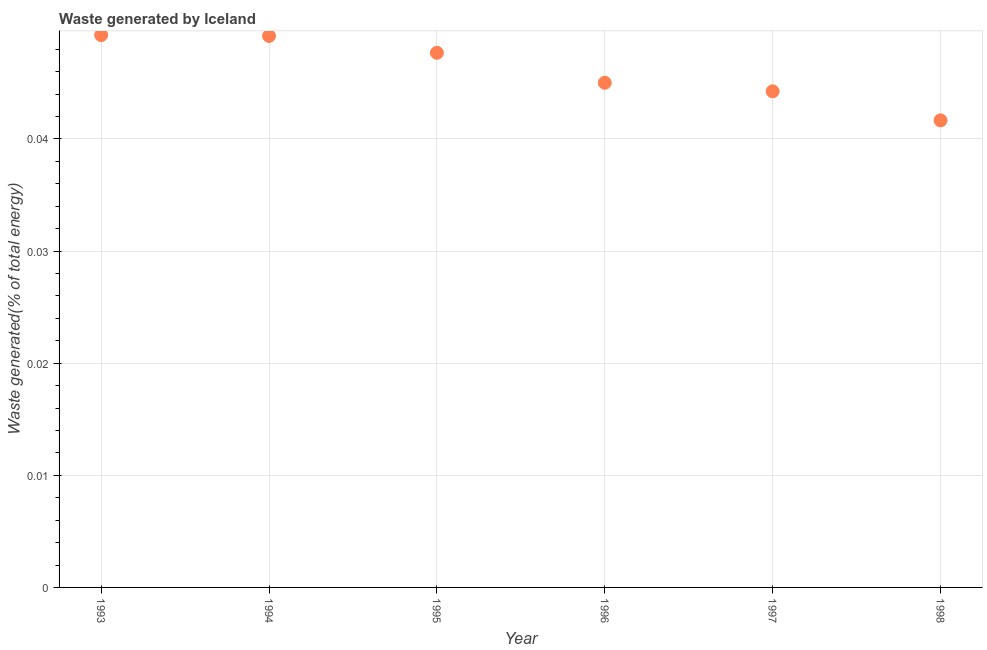What is the amount of waste generated in 1995?
Provide a succinct answer. 0.05. Across all years, what is the maximum amount of waste generated?
Give a very brief answer. 0.05. Across all years, what is the minimum amount of waste generated?
Provide a short and direct response. 0.04. In which year was the amount of waste generated maximum?
Your answer should be very brief. 1993. What is the sum of the amount of waste generated?
Your response must be concise. 0.28. What is the difference between the amount of waste generated in 1993 and 1994?
Ensure brevity in your answer.  7.597910956889248e-5. What is the average amount of waste generated per year?
Make the answer very short. 0.05. What is the median amount of waste generated?
Your answer should be very brief. 0.05. In how many years, is the amount of waste generated greater than 0.026000000000000002 %?
Provide a short and direct response. 6. What is the ratio of the amount of waste generated in 1997 to that in 1998?
Give a very brief answer. 1.06. Is the amount of waste generated in 1994 less than that in 1997?
Make the answer very short. No. Is the difference between the amount of waste generated in 1995 and 1998 greater than the difference between any two years?
Offer a terse response. No. What is the difference between the highest and the second highest amount of waste generated?
Provide a succinct answer. 7.597910956889248e-5. What is the difference between the highest and the lowest amount of waste generated?
Provide a short and direct response. 0.01. Does the graph contain any zero values?
Your response must be concise. No. Does the graph contain grids?
Offer a terse response. Yes. What is the title of the graph?
Your answer should be compact. Waste generated by Iceland. What is the label or title of the X-axis?
Offer a very short reply. Year. What is the label or title of the Y-axis?
Keep it short and to the point. Waste generated(% of total energy). What is the Waste generated(% of total energy) in 1993?
Your response must be concise. 0.05. What is the Waste generated(% of total energy) in 1994?
Keep it short and to the point. 0.05. What is the Waste generated(% of total energy) in 1995?
Give a very brief answer. 0.05. What is the Waste generated(% of total energy) in 1996?
Your answer should be very brief. 0.05. What is the Waste generated(% of total energy) in 1997?
Keep it short and to the point. 0.04. What is the Waste generated(% of total energy) in 1998?
Offer a terse response. 0.04. What is the difference between the Waste generated(% of total energy) in 1993 and 1994?
Provide a succinct answer. 8e-5. What is the difference between the Waste generated(% of total energy) in 1993 and 1995?
Keep it short and to the point. 0. What is the difference between the Waste generated(% of total energy) in 1993 and 1996?
Offer a very short reply. 0. What is the difference between the Waste generated(% of total energy) in 1993 and 1997?
Provide a short and direct response. 0.01. What is the difference between the Waste generated(% of total energy) in 1993 and 1998?
Make the answer very short. 0.01. What is the difference between the Waste generated(% of total energy) in 1994 and 1995?
Make the answer very short. 0. What is the difference between the Waste generated(% of total energy) in 1994 and 1996?
Ensure brevity in your answer.  0. What is the difference between the Waste generated(% of total energy) in 1994 and 1997?
Offer a terse response. 0. What is the difference between the Waste generated(% of total energy) in 1994 and 1998?
Give a very brief answer. 0.01. What is the difference between the Waste generated(% of total energy) in 1995 and 1996?
Provide a short and direct response. 0. What is the difference between the Waste generated(% of total energy) in 1995 and 1997?
Ensure brevity in your answer.  0. What is the difference between the Waste generated(% of total energy) in 1995 and 1998?
Keep it short and to the point. 0.01. What is the difference between the Waste generated(% of total energy) in 1996 and 1997?
Give a very brief answer. 0. What is the difference between the Waste generated(% of total energy) in 1996 and 1998?
Make the answer very short. 0. What is the difference between the Waste generated(% of total energy) in 1997 and 1998?
Your answer should be compact. 0. What is the ratio of the Waste generated(% of total energy) in 1993 to that in 1994?
Your response must be concise. 1. What is the ratio of the Waste generated(% of total energy) in 1993 to that in 1995?
Keep it short and to the point. 1.03. What is the ratio of the Waste generated(% of total energy) in 1993 to that in 1996?
Your response must be concise. 1.09. What is the ratio of the Waste generated(% of total energy) in 1993 to that in 1997?
Offer a terse response. 1.11. What is the ratio of the Waste generated(% of total energy) in 1993 to that in 1998?
Your answer should be very brief. 1.18. What is the ratio of the Waste generated(% of total energy) in 1994 to that in 1995?
Your answer should be compact. 1.03. What is the ratio of the Waste generated(% of total energy) in 1994 to that in 1996?
Your answer should be compact. 1.09. What is the ratio of the Waste generated(% of total energy) in 1994 to that in 1997?
Provide a succinct answer. 1.11. What is the ratio of the Waste generated(% of total energy) in 1994 to that in 1998?
Your response must be concise. 1.18. What is the ratio of the Waste generated(% of total energy) in 1995 to that in 1996?
Keep it short and to the point. 1.06. What is the ratio of the Waste generated(% of total energy) in 1995 to that in 1997?
Your response must be concise. 1.08. What is the ratio of the Waste generated(% of total energy) in 1995 to that in 1998?
Offer a very short reply. 1.15. What is the ratio of the Waste generated(% of total energy) in 1996 to that in 1997?
Provide a succinct answer. 1.02. What is the ratio of the Waste generated(% of total energy) in 1996 to that in 1998?
Provide a short and direct response. 1.08. What is the ratio of the Waste generated(% of total energy) in 1997 to that in 1998?
Provide a succinct answer. 1.06. 